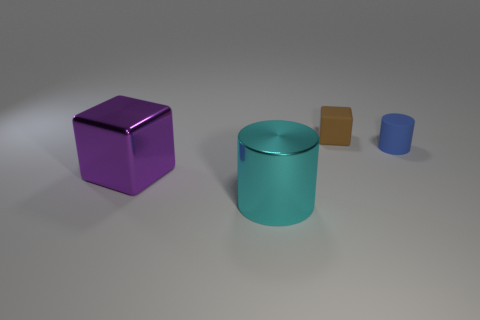Add 1 purple metallic cubes. How many objects exist? 5 Subtract all large blue matte cylinders. Subtract all big cylinders. How many objects are left? 3 Add 3 blue cylinders. How many blue cylinders are left? 4 Add 1 cyan metal things. How many cyan metal things exist? 2 Subtract 0 blue cubes. How many objects are left? 4 